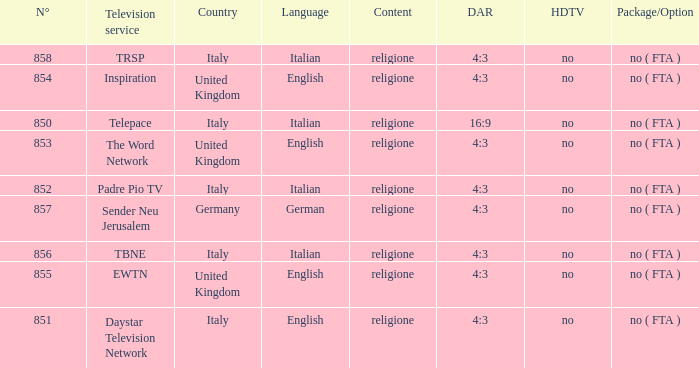What television service are in the united kingdom and n° is greater than 854.0? EWTN. 